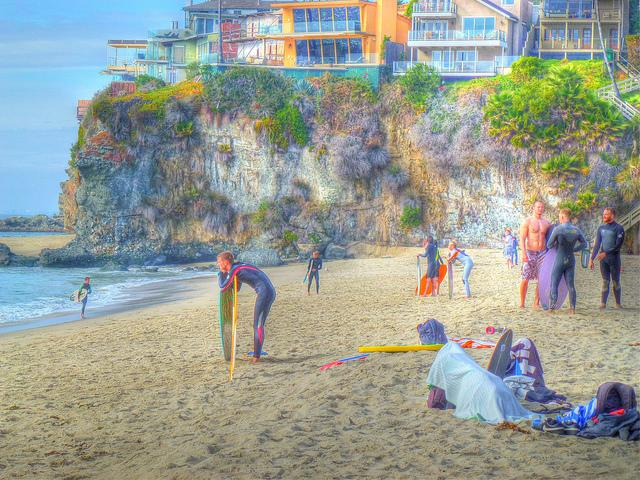What is this image?

Choices:
A) puzzle
B) photo
C) photoshopped picture
D) drawing drawing 